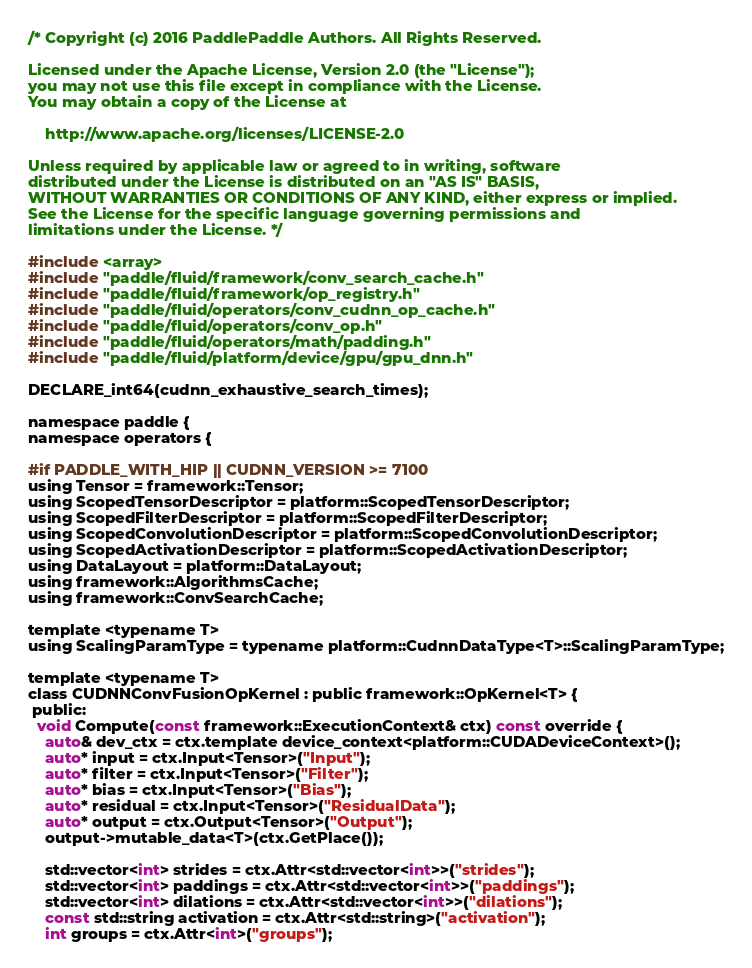<code> <loc_0><loc_0><loc_500><loc_500><_Cuda_>/* Copyright (c) 2016 PaddlePaddle Authors. All Rights Reserved.

Licensed under the Apache License, Version 2.0 (the "License");
you may not use this file except in compliance with the License.
You may obtain a copy of the License at

    http://www.apache.org/licenses/LICENSE-2.0

Unless required by applicable law or agreed to in writing, software
distributed under the License is distributed on an "AS IS" BASIS,
WITHOUT WARRANTIES OR CONDITIONS OF ANY KIND, either express or implied.
See the License for the specific language governing permissions and
limitations under the License. */

#include <array>
#include "paddle/fluid/framework/conv_search_cache.h"
#include "paddle/fluid/framework/op_registry.h"
#include "paddle/fluid/operators/conv_cudnn_op_cache.h"
#include "paddle/fluid/operators/conv_op.h"
#include "paddle/fluid/operators/math/padding.h"
#include "paddle/fluid/platform/device/gpu/gpu_dnn.h"

DECLARE_int64(cudnn_exhaustive_search_times);

namespace paddle {
namespace operators {

#if PADDLE_WITH_HIP || CUDNN_VERSION >= 7100
using Tensor = framework::Tensor;
using ScopedTensorDescriptor = platform::ScopedTensorDescriptor;
using ScopedFilterDescriptor = platform::ScopedFilterDescriptor;
using ScopedConvolutionDescriptor = platform::ScopedConvolutionDescriptor;
using ScopedActivationDescriptor = platform::ScopedActivationDescriptor;
using DataLayout = platform::DataLayout;
using framework::AlgorithmsCache;
using framework::ConvSearchCache;

template <typename T>
using ScalingParamType = typename platform::CudnnDataType<T>::ScalingParamType;

template <typename T>
class CUDNNConvFusionOpKernel : public framework::OpKernel<T> {
 public:
  void Compute(const framework::ExecutionContext& ctx) const override {
    auto& dev_ctx = ctx.template device_context<platform::CUDADeviceContext>();
    auto* input = ctx.Input<Tensor>("Input");
    auto* filter = ctx.Input<Tensor>("Filter");
    auto* bias = ctx.Input<Tensor>("Bias");
    auto* residual = ctx.Input<Tensor>("ResidualData");
    auto* output = ctx.Output<Tensor>("Output");
    output->mutable_data<T>(ctx.GetPlace());

    std::vector<int> strides = ctx.Attr<std::vector<int>>("strides");
    std::vector<int> paddings = ctx.Attr<std::vector<int>>("paddings");
    std::vector<int> dilations = ctx.Attr<std::vector<int>>("dilations");
    const std::string activation = ctx.Attr<std::string>("activation");
    int groups = ctx.Attr<int>("groups");</code> 